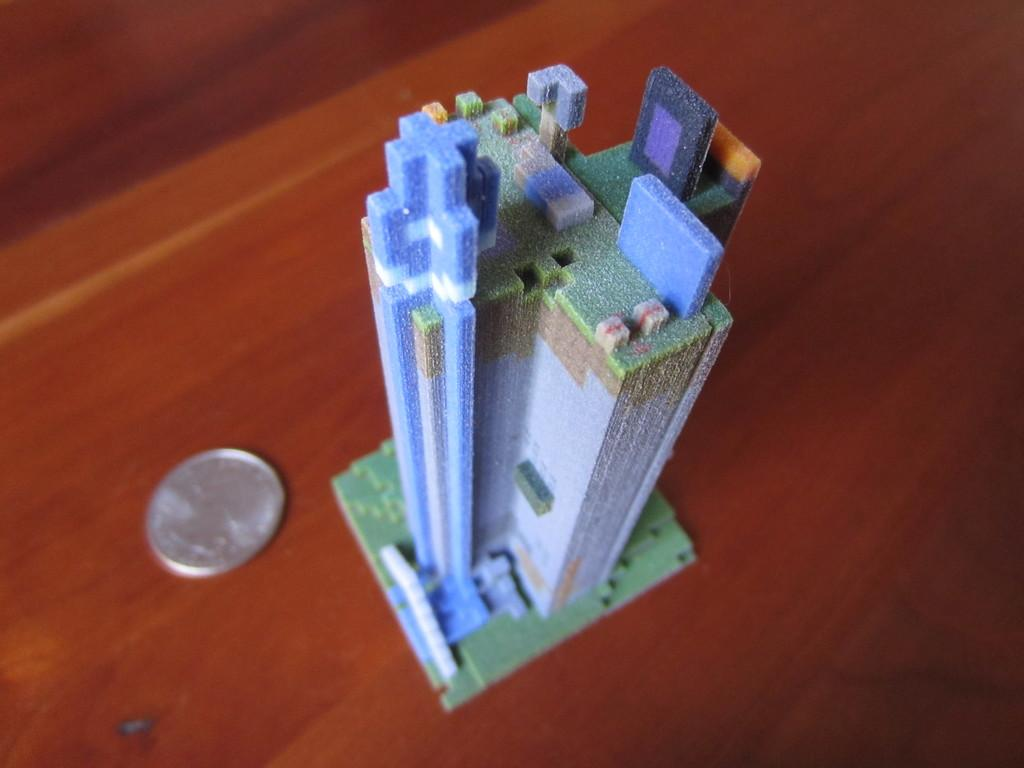What is the main subject in the center of the image? There is a duplicate of a building in the center of the image. What object is located beside the building? There is a coin beside the building. What piece of furniture is at the bottom of the image? There is a table at the bottom of the image. Who is the expert on the topic of balance in the image? There is no expert on the topic of balance present in the image. What question is being asked in the image? There is no question being asked in the image. 